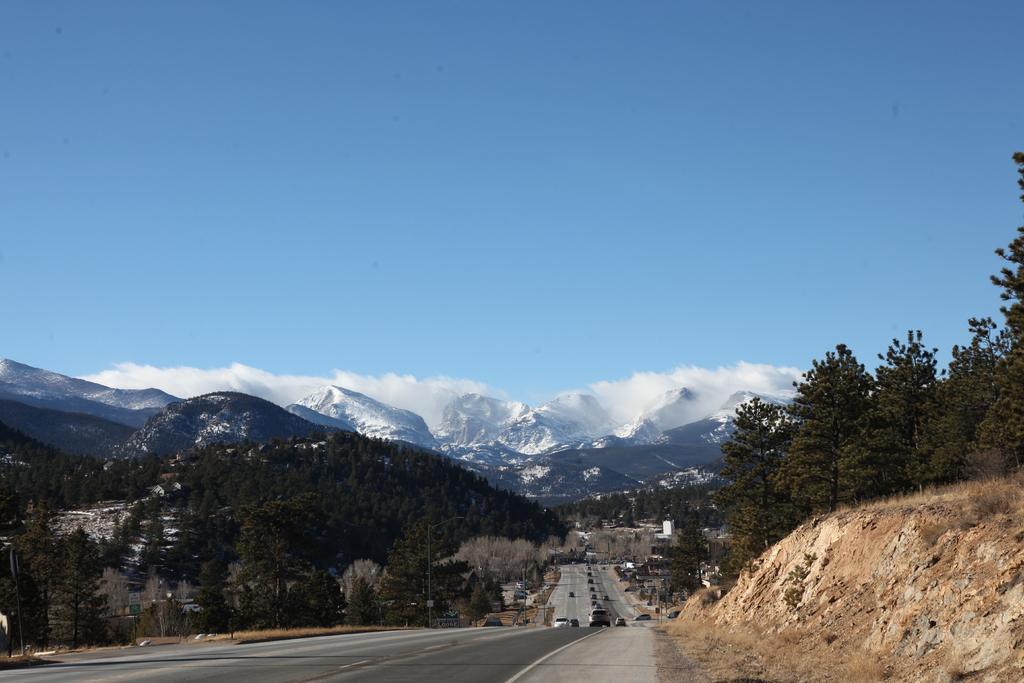Describe this image in one or two sentences. In the center of the image we can see group of vehicles parked on the road. In the background, we can see a group of trees, poles, mountains and the cloudy sky. 